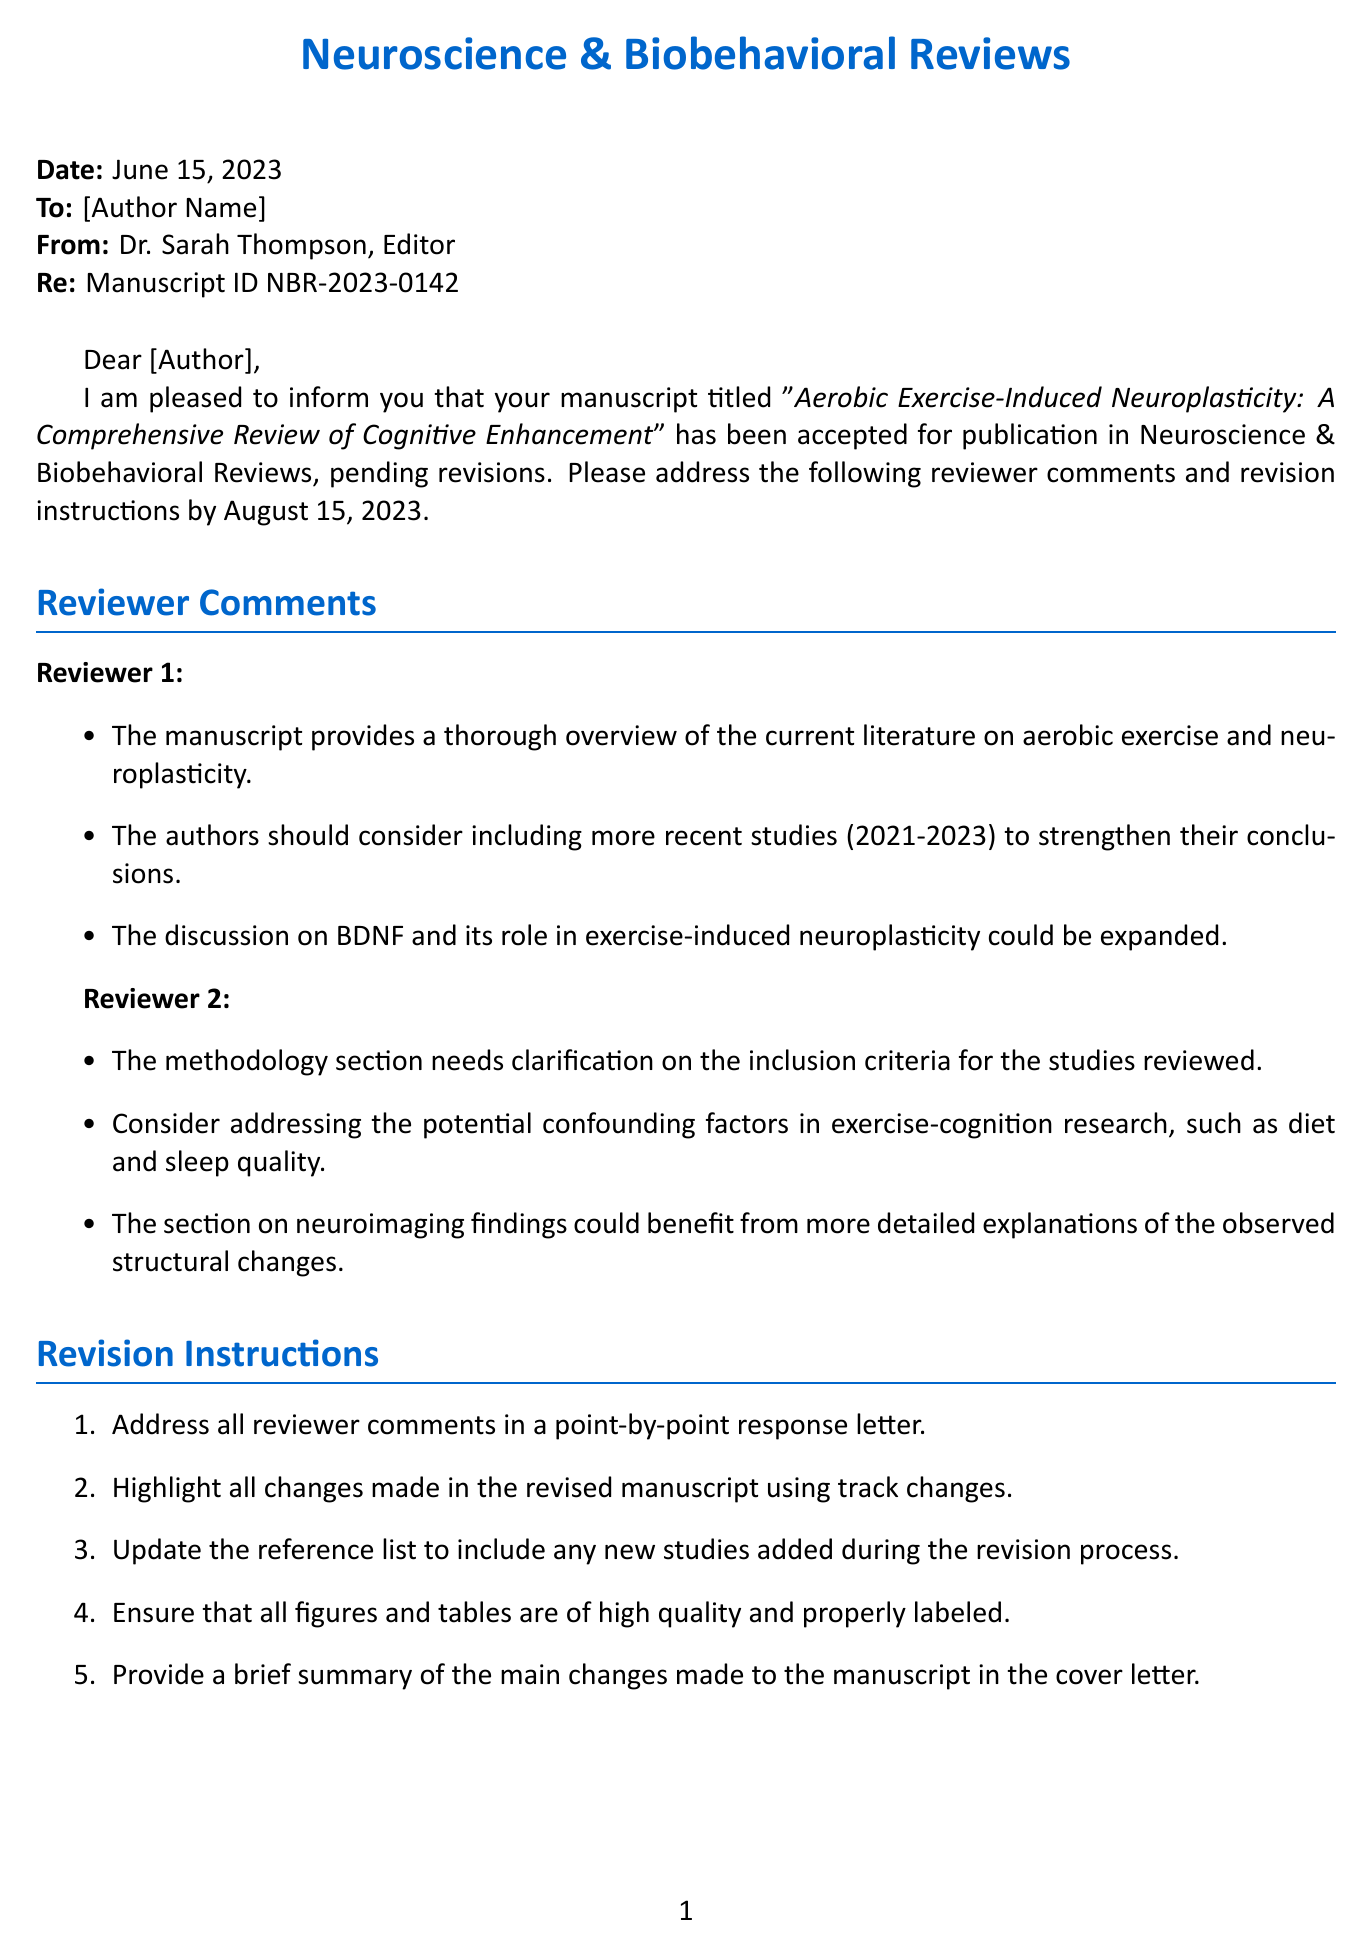What is the title of the manuscript? The title of the manuscript is mentioned at the beginning of the document and reflects the research focus.
Answer: Aerobic Exercise-Induced Neuroplasticity: A Comprehensive Review of Cognitive Enhancement Who is the editor of the journal? The editor's name appears in the address line of the letter and is responsible for the acceptance and review process.
Answer: Dr. Sarah Thompson What is the manuscript ID? The manuscript ID is a unique identifier assigned to the submission and is referenced for tracking purposes.
Answer: NBR-2023-0142 What is the acceptance date of the manuscript? The acceptance date can be found at the top of the letter and indicates when the manuscript was officially accepted.
Answer: June 15, 2023 What is the revision deadline? The revision deadline is the date by which the authors must submit their revised manuscript.
Answer: August 15, 2023 How many reviewers provided comments on the manuscript? The number of reviewers is indicated by how many separate sections are dedicated to their feedback.
Answer: 2 What specific guideline regarding the abstract word count is mentioned? The guideline specifies a limit for the abstract, which is an important consideration for manuscript revision.
Answer: 250 words What are authors instructed to do with their revisions? The instructions detail specific actions that authors must take when revising their manuscript after receiving comments.
Answer: Address all reviewer comments in a point-by-point response letter What additional resource is provided for potential funding opportunities? The additional resources section includes specific organizations and their functions related to research funding.
Answer: NIH Brain Initiative 